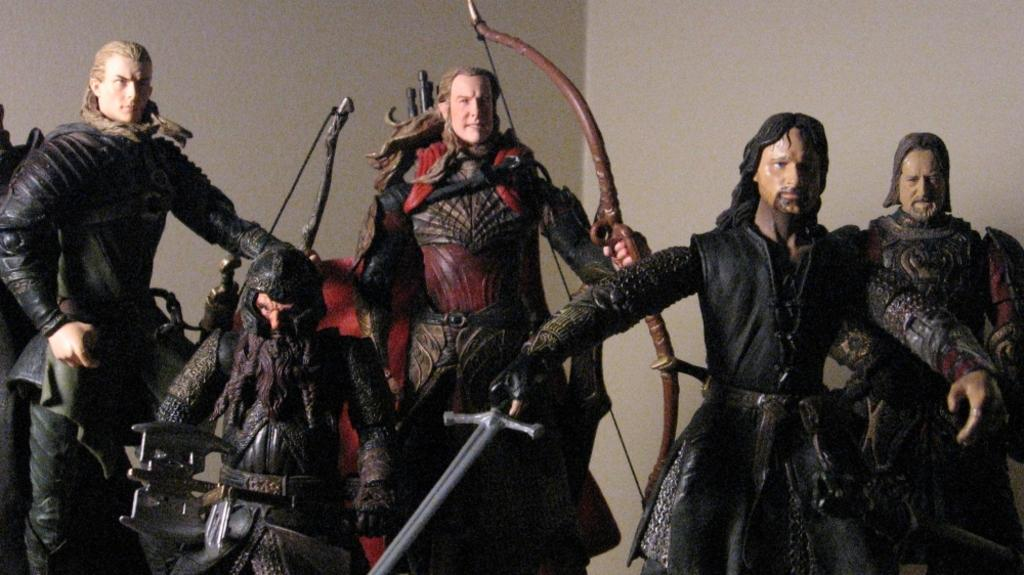What type of objects can be seen in the image? There are statues, a sword, and bows in the image. What is the background of the image? There is a wall in the image. What is the plot of the story being told by the boy in the image? There is no boy present in the image, so there is no story being told. 